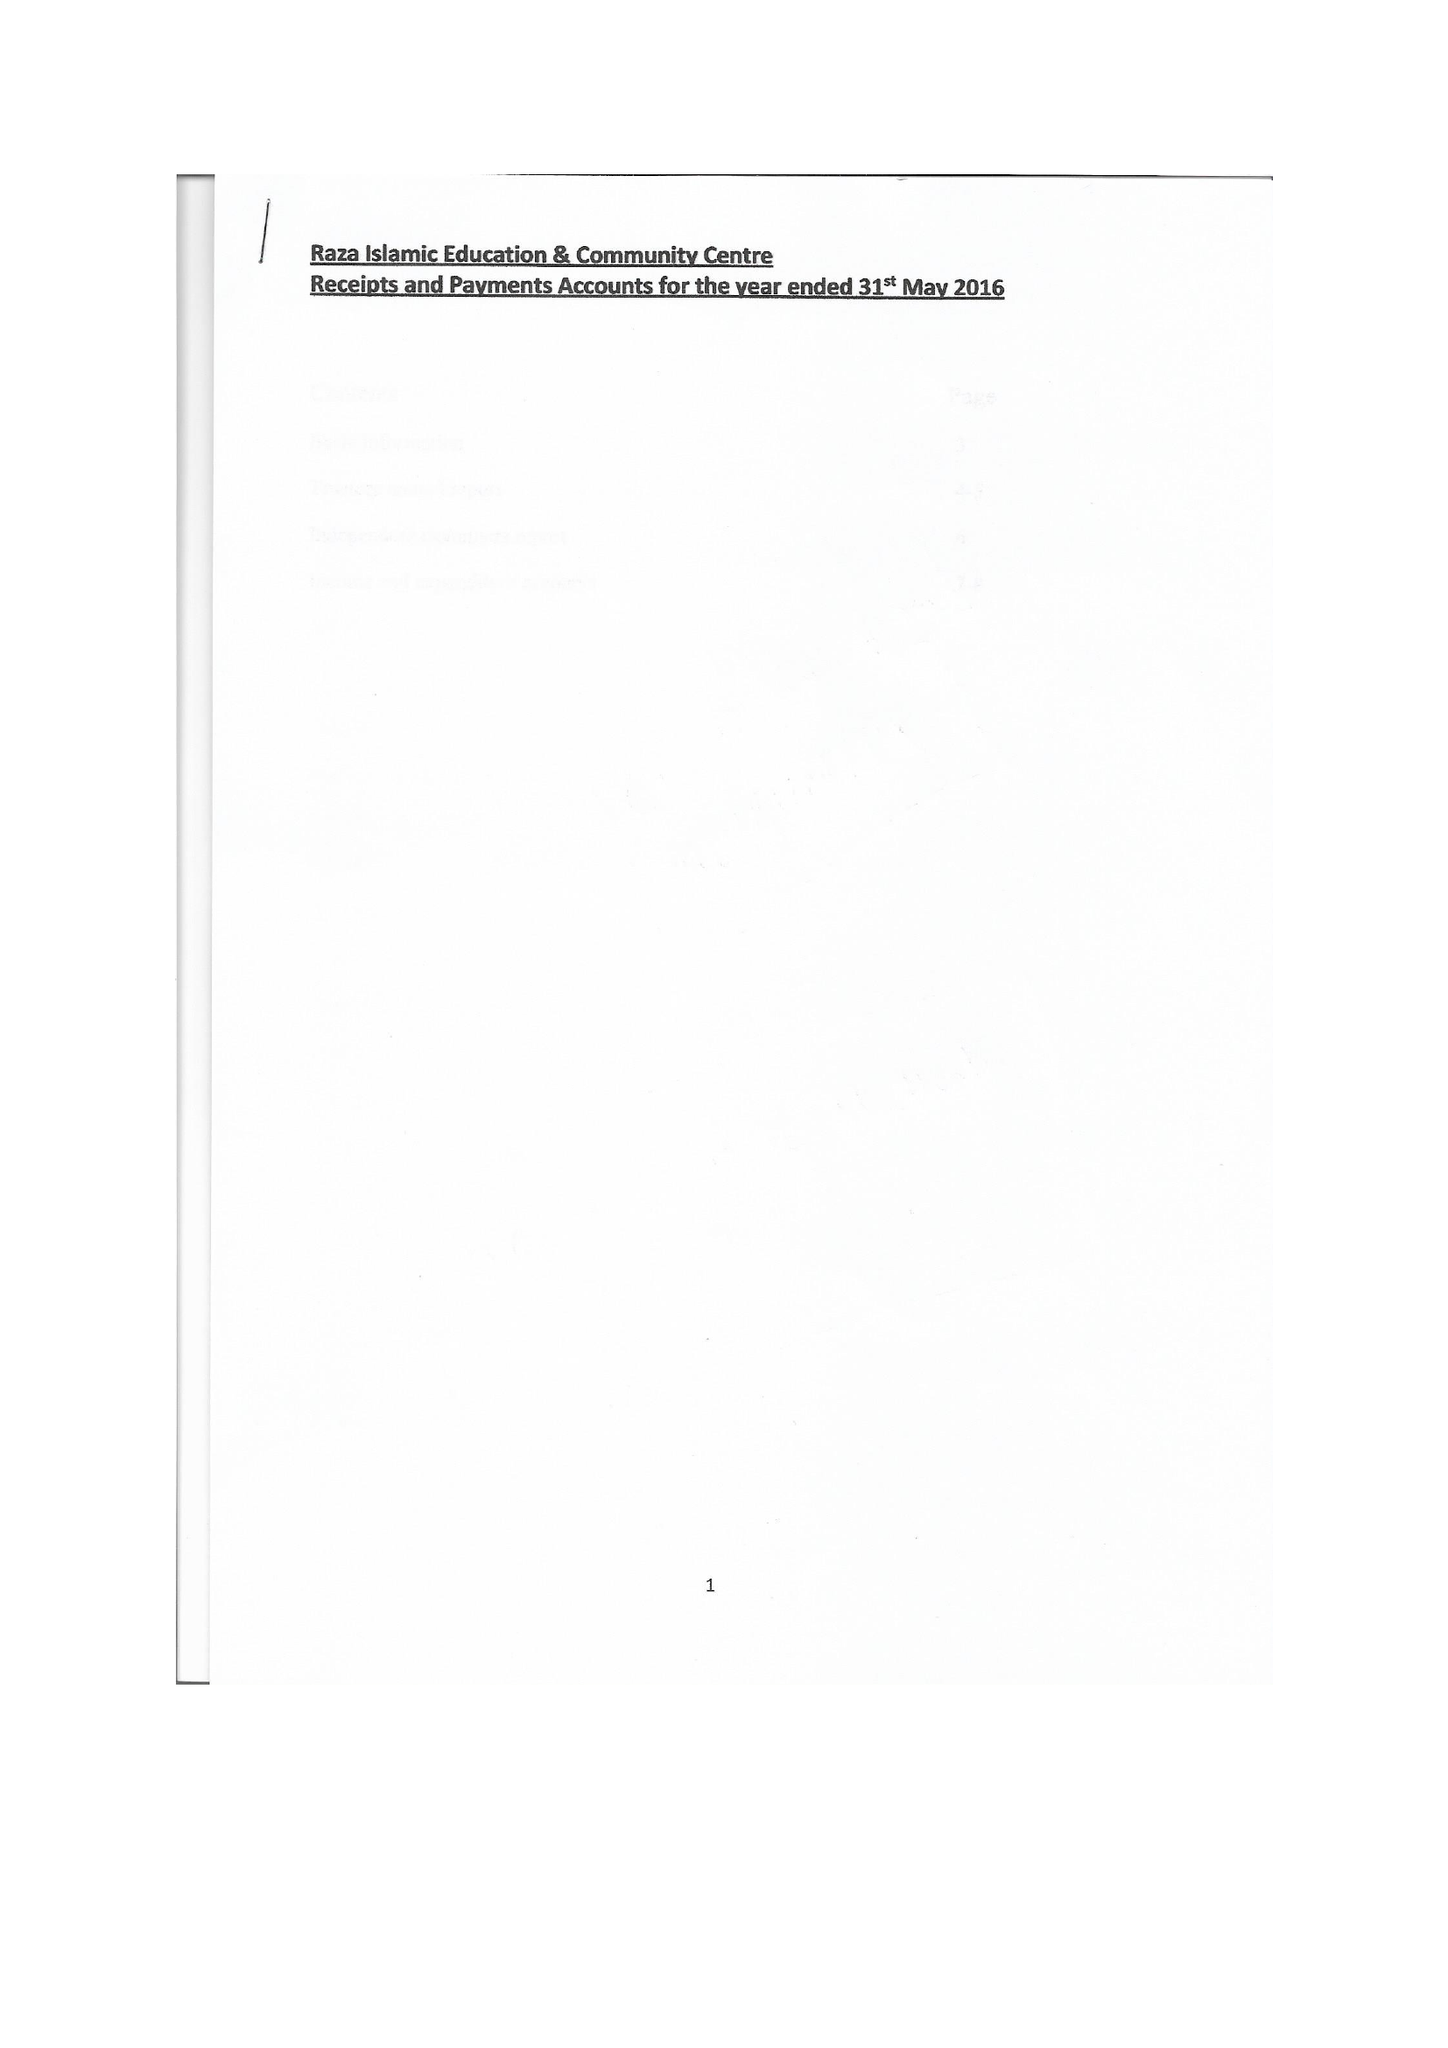What is the value for the spending_annually_in_british_pounds?
Answer the question using a single word or phrase. 29936.00 